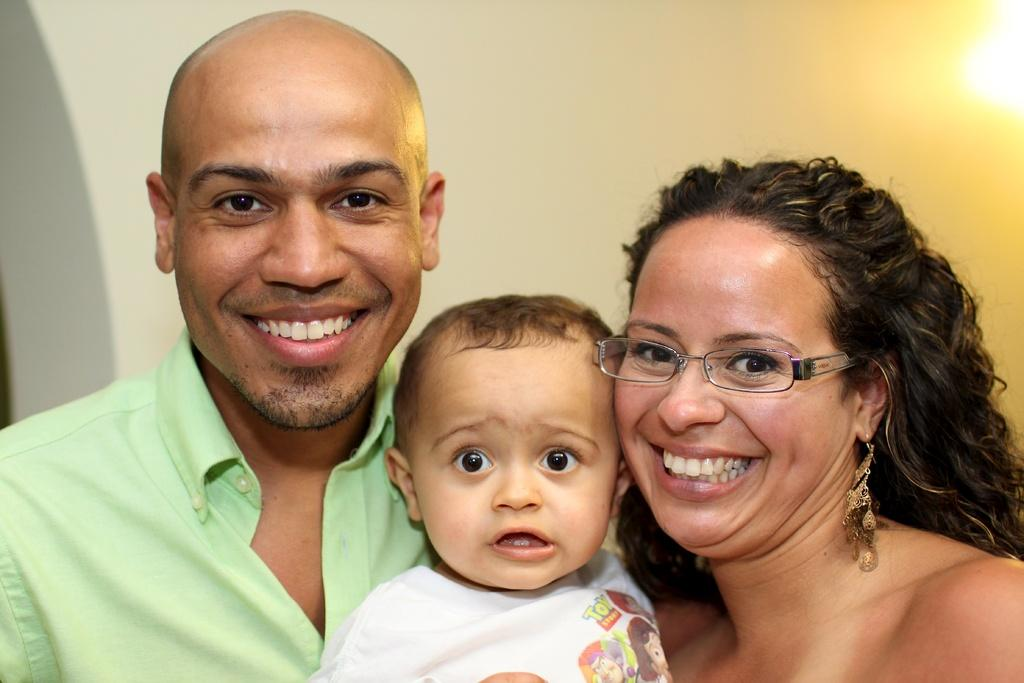What is the main subject in the center of the image? There is a kid in the center of the image. What are the expressions of the people in the image? Two persons are smiling in the image. Can you describe the appearance of one of the persons? One person is wearing glasses. What can be seen in the background of the image? There is a wall and light in the background of the image. What type of sofa is visible in the image? There is no sofa present in the image. What kind of lumber is being used to build the wall in the background? The image does not provide information about the type of lumber used to build the wall in the background. 